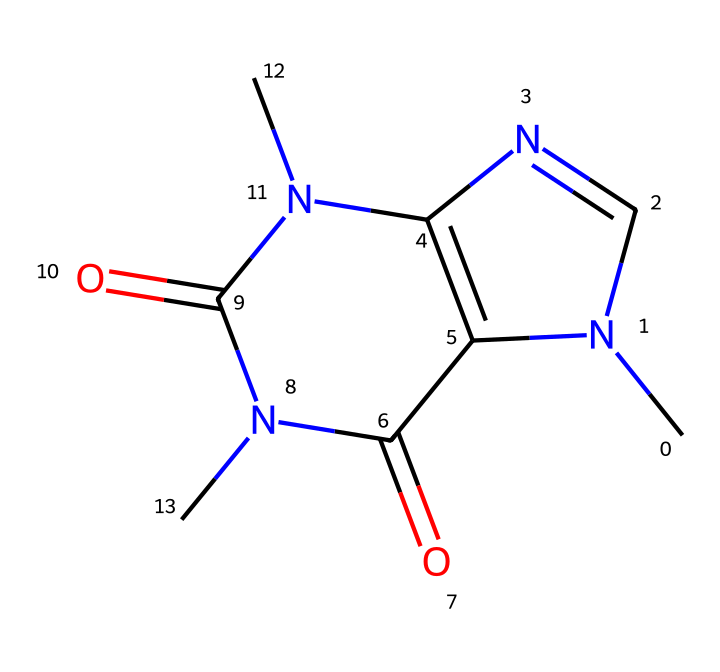What is the molecular formula of caffeine? By analyzing the SMILES representation, we count the atoms: there are 8 carbons (C), 10 hydrogens (H), and 4 nitrogens (N) present in the structure, thus arriving at the molecular formula C8H10N4O2 (including the oxygen atoms).
Answer: C8H10N4O2 How many nitrogen atoms are in caffeine? From the SMILES string, we can identify the presence of four nitrogen atoms ('N'). By counting each 'N' in the structure, we confirm the total.
Answer: 4 What type of organic compound is caffeine classified as? Given its structure, which includes nitrogen and carbon, caffeine is classified as an alkaloid, specifically a purine alkaloid due to its complex ring structure containing nitrogen atoms.
Answer: alkaloid Which atoms are responsible for the psychoactive effects of caffeine? The nitrogen atoms play a critical role in the psychoactive effects of caffeine as they are part of its molecular structure and help in neurotransmitter modulation, thus influencing brain activity.
Answer: nitrogen How many rings are in the caffeine structure? Analyzing the chemical structure, we see that caffeine has a total of two fused rings that make up its core structure, characteristic of many alkaloids.
Answer: 2 What functional groups can be identified in caffeine? The chemical structure of caffeine contains two carbonyl (C=O) functional groups, which are part of the amide groups that play a role in its biological activity.
Answer: carbonyl What is the impact of caffeine on the central nervous system? Caffeine acts as a stimulant on the central nervous system, increasing alertness and reducing the perception of fatigue, which is primarily due to its interaction with adenosine receptors, involving its nitrogen content.
Answer: stimulant 